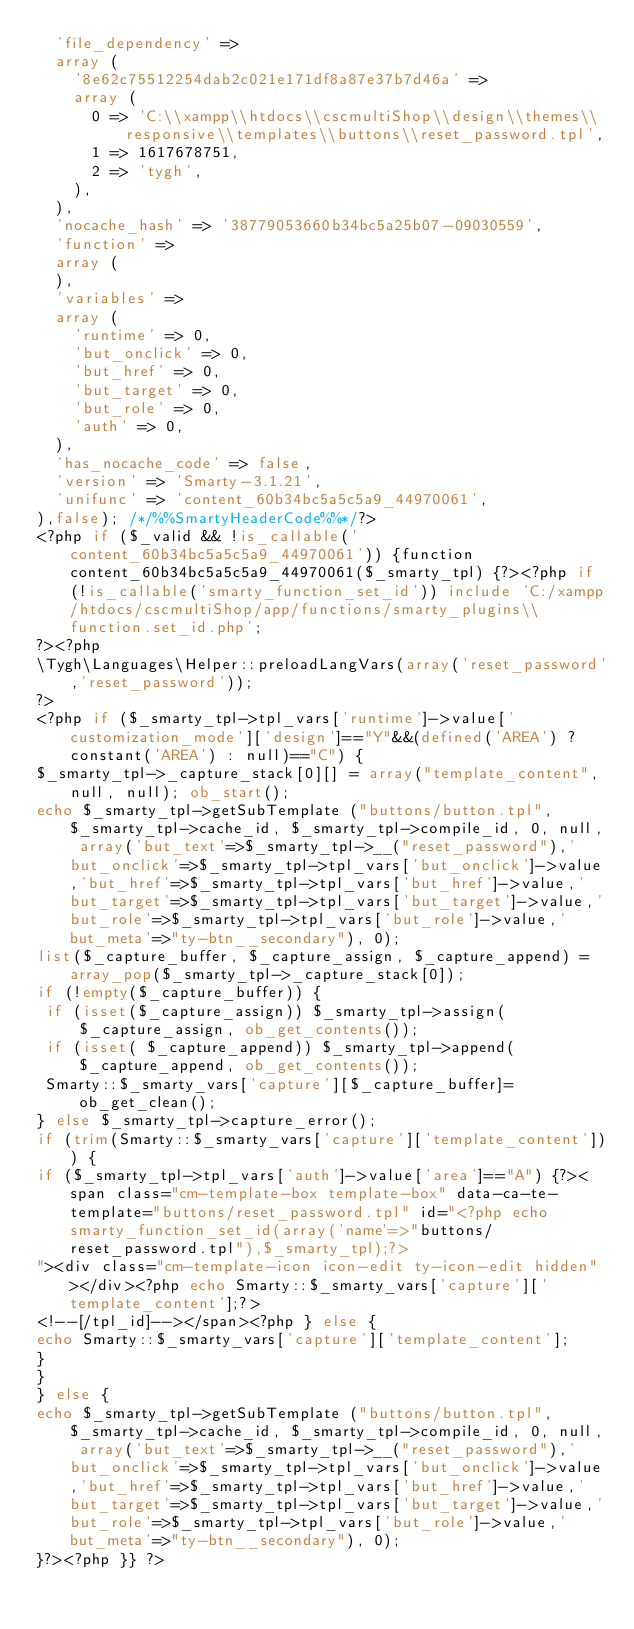Convert code to text. <code><loc_0><loc_0><loc_500><loc_500><_PHP_>  'file_dependency' => 
  array (
    '8e62c75512254dab2c021e171df8a87e37b7d46a' => 
    array (
      0 => 'C:\\xampp\\htdocs\\cscmultiShop\\design\\themes\\responsive\\templates\\buttons\\reset_password.tpl',
      1 => 1617678751,
      2 => 'tygh',
    ),
  ),
  'nocache_hash' => '38779053660b34bc5a25b07-09030559',
  'function' => 
  array (
  ),
  'variables' => 
  array (
    'runtime' => 0,
    'but_onclick' => 0,
    'but_href' => 0,
    'but_target' => 0,
    'but_role' => 0,
    'auth' => 0,
  ),
  'has_nocache_code' => false,
  'version' => 'Smarty-3.1.21',
  'unifunc' => 'content_60b34bc5a5c5a9_44970061',
),false); /*/%%SmartyHeaderCode%%*/?>
<?php if ($_valid && !is_callable('content_60b34bc5a5c5a9_44970061')) {function content_60b34bc5a5c5a9_44970061($_smarty_tpl) {?><?php if (!is_callable('smarty_function_set_id')) include 'C:/xampp/htdocs/cscmultiShop/app/functions/smarty_plugins\\function.set_id.php';
?><?php
\Tygh\Languages\Helper::preloadLangVars(array('reset_password','reset_password'));
?>
<?php if ($_smarty_tpl->tpl_vars['runtime']->value['customization_mode']['design']=="Y"&&(defined('AREA') ? constant('AREA') : null)=="C") {
$_smarty_tpl->_capture_stack[0][] = array("template_content", null, null); ob_start();
echo $_smarty_tpl->getSubTemplate ("buttons/button.tpl", $_smarty_tpl->cache_id, $_smarty_tpl->compile_id, 0, null, array('but_text'=>$_smarty_tpl->__("reset_password"),'but_onclick'=>$_smarty_tpl->tpl_vars['but_onclick']->value,'but_href'=>$_smarty_tpl->tpl_vars['but_href']->value,'but_target'=>$_smarty_tpl->tpl_vars['but_target']->value,'but_role'=>$_smarty_tpl->tpl_vars['but_role']->value,'but_meta'=>"ty-btn__secondary"), 0);
list($_capture_buffer, $_capture_assign, $_capture_append) = array_pop($_smarty_tpl->_capture_stack[0]);
if (!empty($_capture_buffer)) {
 if (isset($_capture_assign)) $_smarty_tpl->assign($_capture_assign, ob_get_contents());
 if (isset( $_capture_append)) $_smarty_tpl->append( $_capture_append, ob_get_contents());
 Smarty::$_smarty_vars['capture'][$_capture_buffer]=ob_get_clean();
} else $_smarty_tpl->capture_error();
if (trim(Smarty::$_smarty_vars['capture']['template_content'])) {
if ($_smarty_tpl->tpl_vars['auth']->value['area']=="A") {?><span class="cm-template-box template-box" data-ca-te-template="buttons/reset_password.tpl" id="<?php echo smarty_function_set_id(array('name'=>"buttons/reset_password.tpl"),$_smarty_tpl);?>
"><div class="cm-template-icon icon-edit ty-icon-edit hidden"></div><?php echo Smarty::$_smarty_vars['capture']['template_content'];?>
<!--[/tpl_id]--></span><?php } else {
echo Smarty::$_smarty_vars['capture']['template_content'];
}
}
} else {
echo $_smarty_tpl->getSubTemplate ("buttons/button.tpl", $_smarty_tpl->cache_id, $_smarty_tpl->compile_id, 0, null, array('but_text'=>$_smarty_tpl->__("reset_password"),'but_onclick'=>$_smarty_tpl->tpl_vars['but_onclick']->value,'but_href'=>$_smarty_tpl->tpl_vars['but_href']->value,'but_target'=>$_smarty_tpl->tpl_vars['but_target']->value,'but_role'=>$_smarty_tpl->tpl_vars['but_role']->value,'but_meta'=>"ty-btn__secondary"), 0);
}?><?php }} ?>
</code> 